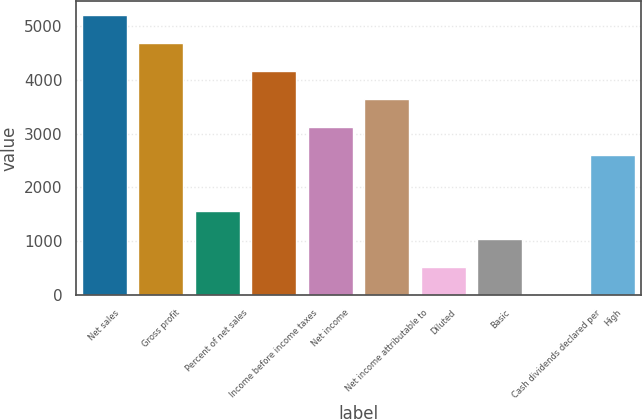<chart> <loc_0><loc_0><loc_500><loc_500><bar_chart><fcel>Net sales<fcel>Gross profit<fcel>Percent of net sales<fcel>Income before income taxes<fcel>Net income<fcel>Net income attributable to<fcel>Diluted<fcel>Basic<fcel>Cash dividends declared per<fcel>High<nl><fcel>5203.02<fcel>4682.77<fcel>1561.28<fcel>4162.53<fcel>3122.03<fcel>3642.28<fcel>520.79<fcel>1041.03<fcel>0.55<fcel>2601.78<nl></chart> 